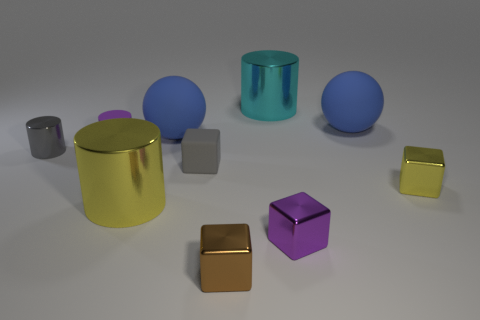What number of small metal objects are behind the metal object that is behind the tiny cylinder to the left of the purple cylinder?
Your response must be concise. 0. Do the matte block and the metal cylinder in front of the gray matte cube have the same color?
Offer a terse response. No. What number of things are either matte balls that are on the left side of the cyan cylinder or things on the left side of the small purple cube?
Give a very brief answer. 7. Is the number of things on the left side of the purple cube greater than the number of purple things to the right of the small brown metal block?
Ensure brevity in your answer.  Yes. There is a gray thing to the right of the big thing that is in front of the small purple thing behind the gray shiny cylinder; what is it made of?
Ensure brevity in your answer.  Rubber. Is the shape of the purple object in front of the big yellow cylinder the same as the gray thing that is to the right of the purple rubber cylinder?
Keep it short and to the point. Yes. Are there any yellow shiny cubes that have the same size as the brown block?
Your response must be concise. Yes. How many cyan things are either small objects or rubber blocks?
Keep it short and to the point. 0. How many small objects are the same color as the rubber cylinder?
Give a very brief answer. 1. Is there anything else that is the same shape as the big cyan shiny thing?
Make the answer very short. Yes. 